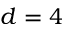Convert formula to latex. <formula><loc_0><loc_0><loc_500><loc_500>d = 4</formula> 